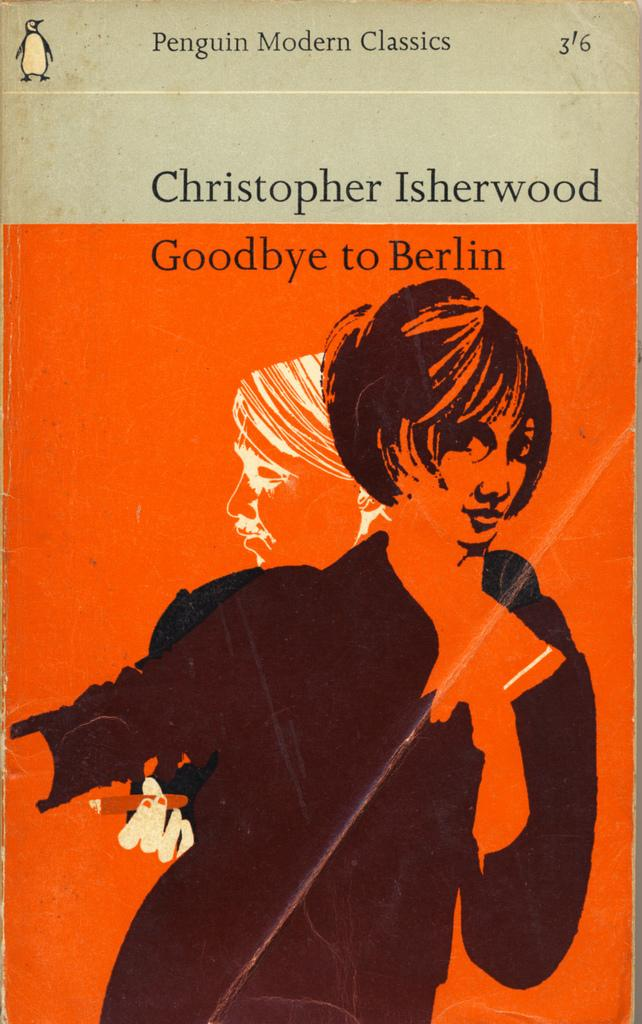What is present in the image that features a visual representation? There is a poster in the image. What can be seen on the poster? There are two persons depicted on the poster. Is there any text on the poster? Yes, there is text written on the poster. What type of bird can be seen smashing the wren on the poster? There is no bird or wren present on the poster; it features two persons and text. 